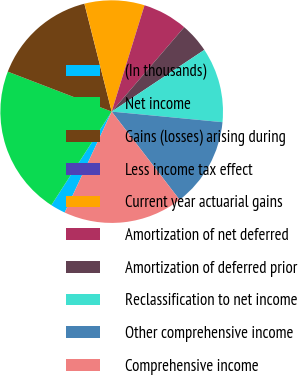<chart> <loc_0><loc_0><loc_500><loc_500><pie_chart><fcel>(In thousands)<fcel>Net income<fcel>Gains (losses) arising during<fcel>Less income tax effect<fcel>Current year actuarial gains<fcel>Amortization of net deferred<fcel>Amortization of deferred prior<fcel>Reclassification to net income<fcel>Other comprehensive income<fcel>Comprehensive income<nl><fcel>2.18%<fcel>21.73%<fcel>15.21%<fcel>0.01%<fcel>8.7%<fcel>6.53%<fcel>4.35%<fcel>10.87%<fcel>13.04%<fcel>17.38%<nl></chart> 